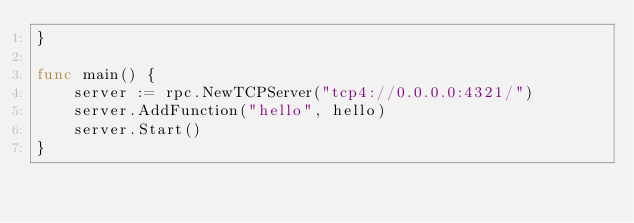Convert code to text. <code><loc_0><loc_0><loc_500><loc_500><_Go_>}

func main() {
	server := rpc.NewTCPServer("tcp4://0.0.0.0:4321/")
	server.AddFunction("hello", hello)
	server.Start()
}
</code> 